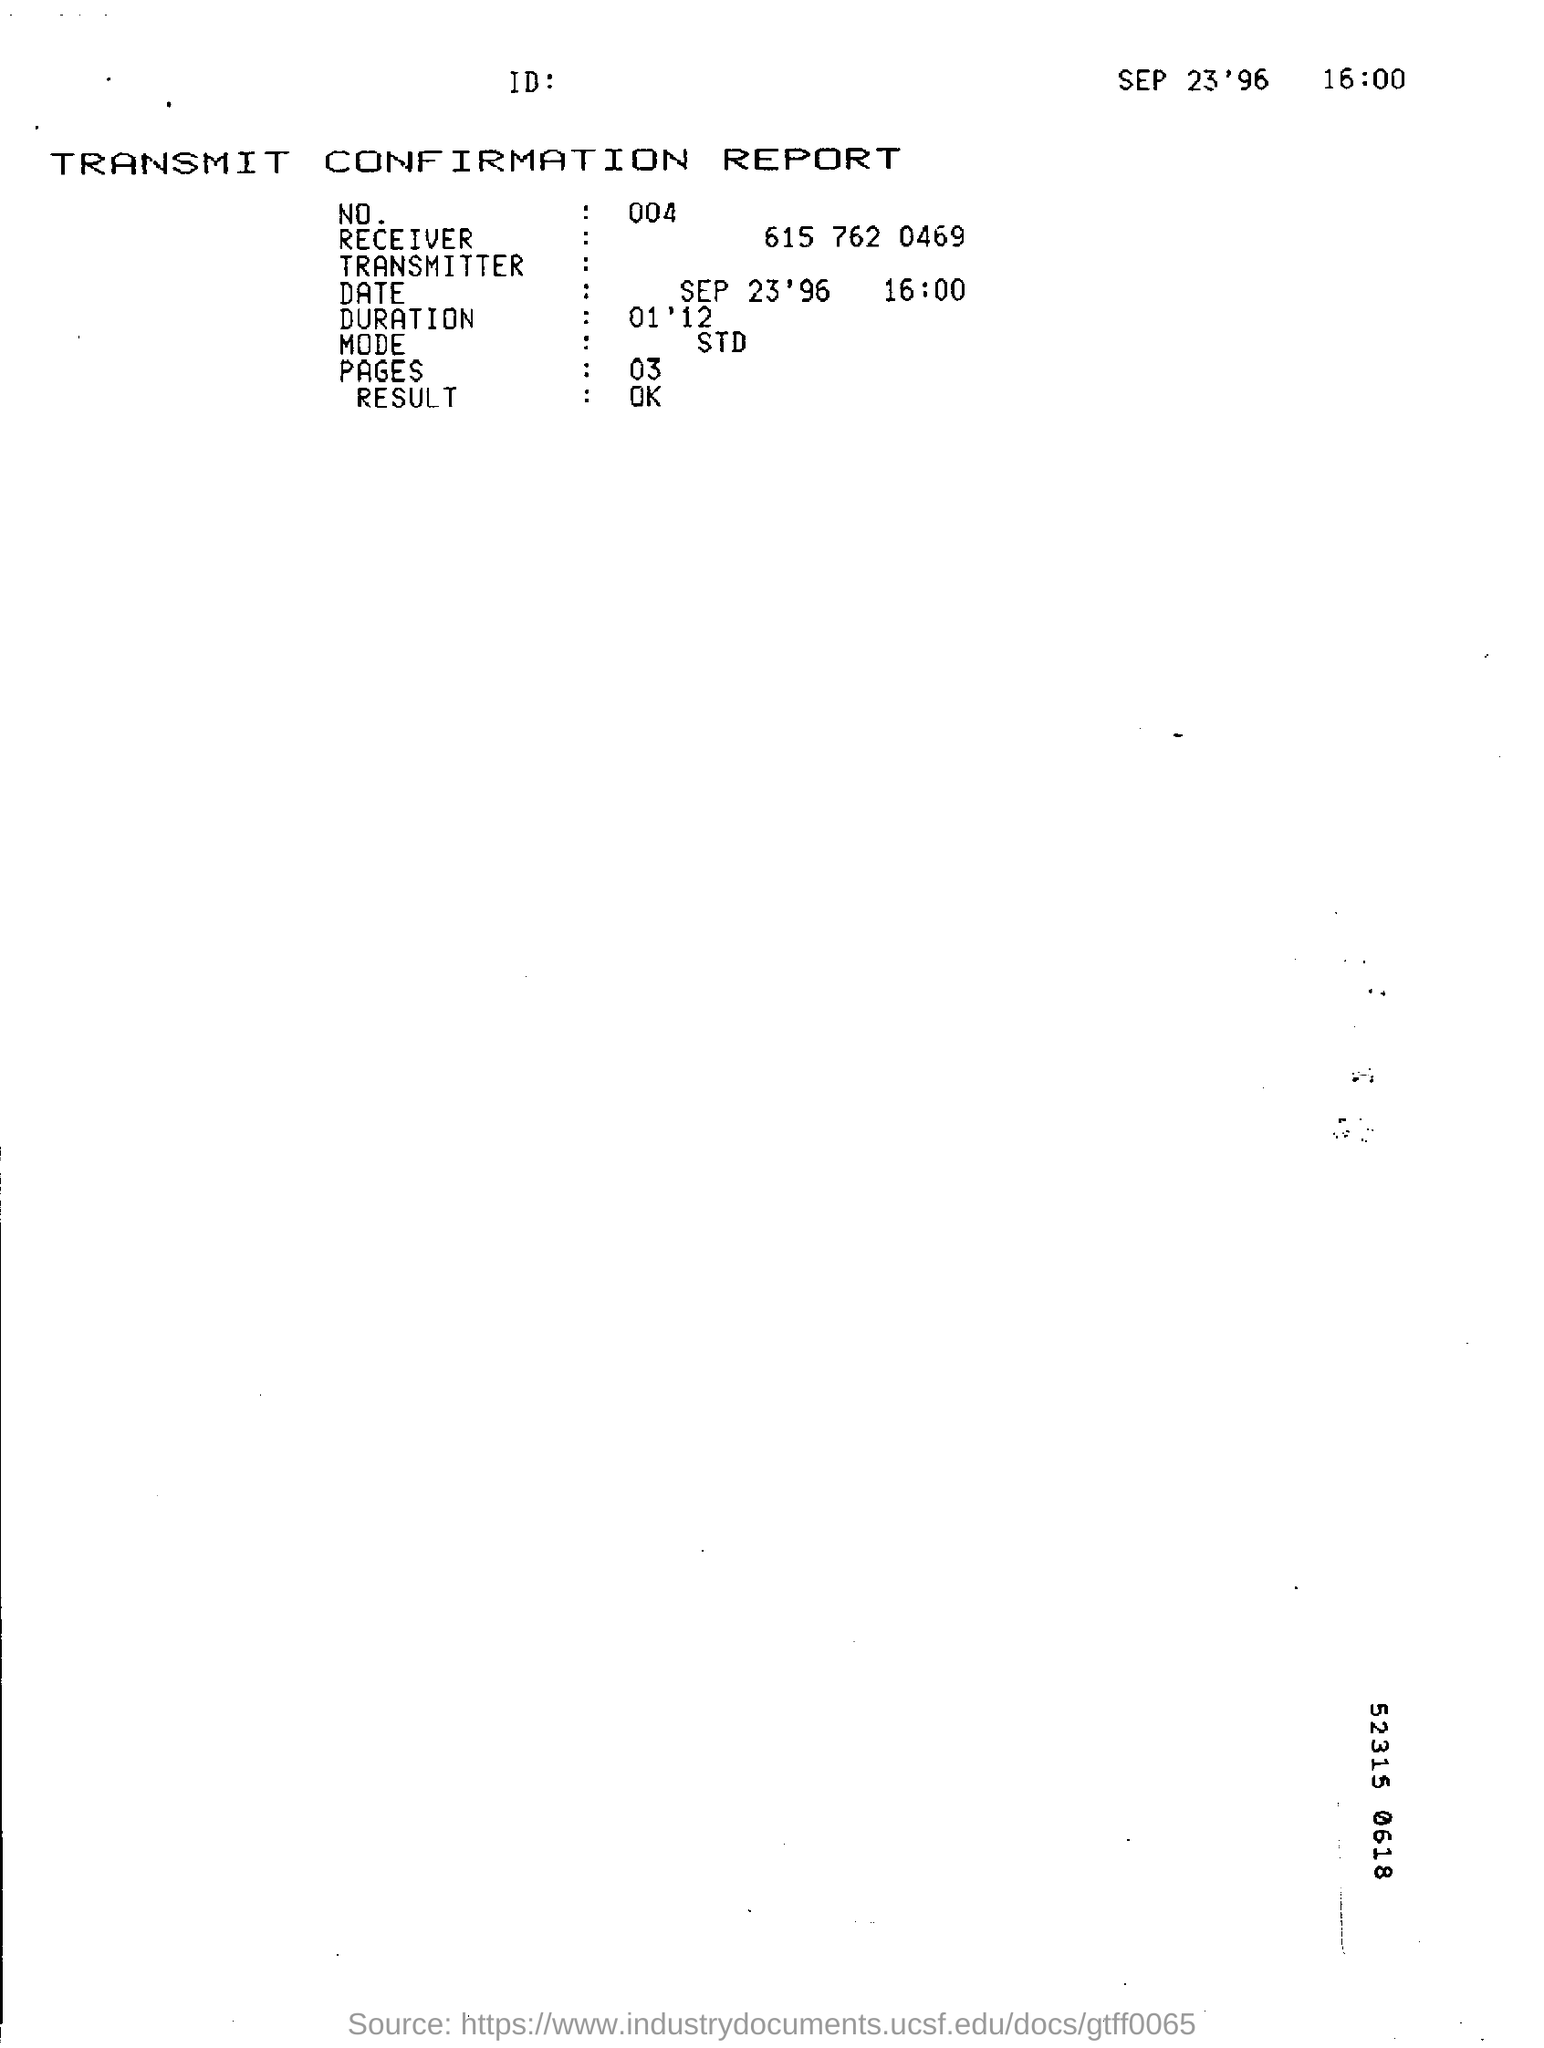Point out several critical features in this image. The name of the report is the "Transmit Confirmation Report. The time mentioned in the report is 4:00 PM. The result shown in the report is "ok.. The duration time mentioned in the report is 1 minute and 12 seconds. There are three pages in the report. 